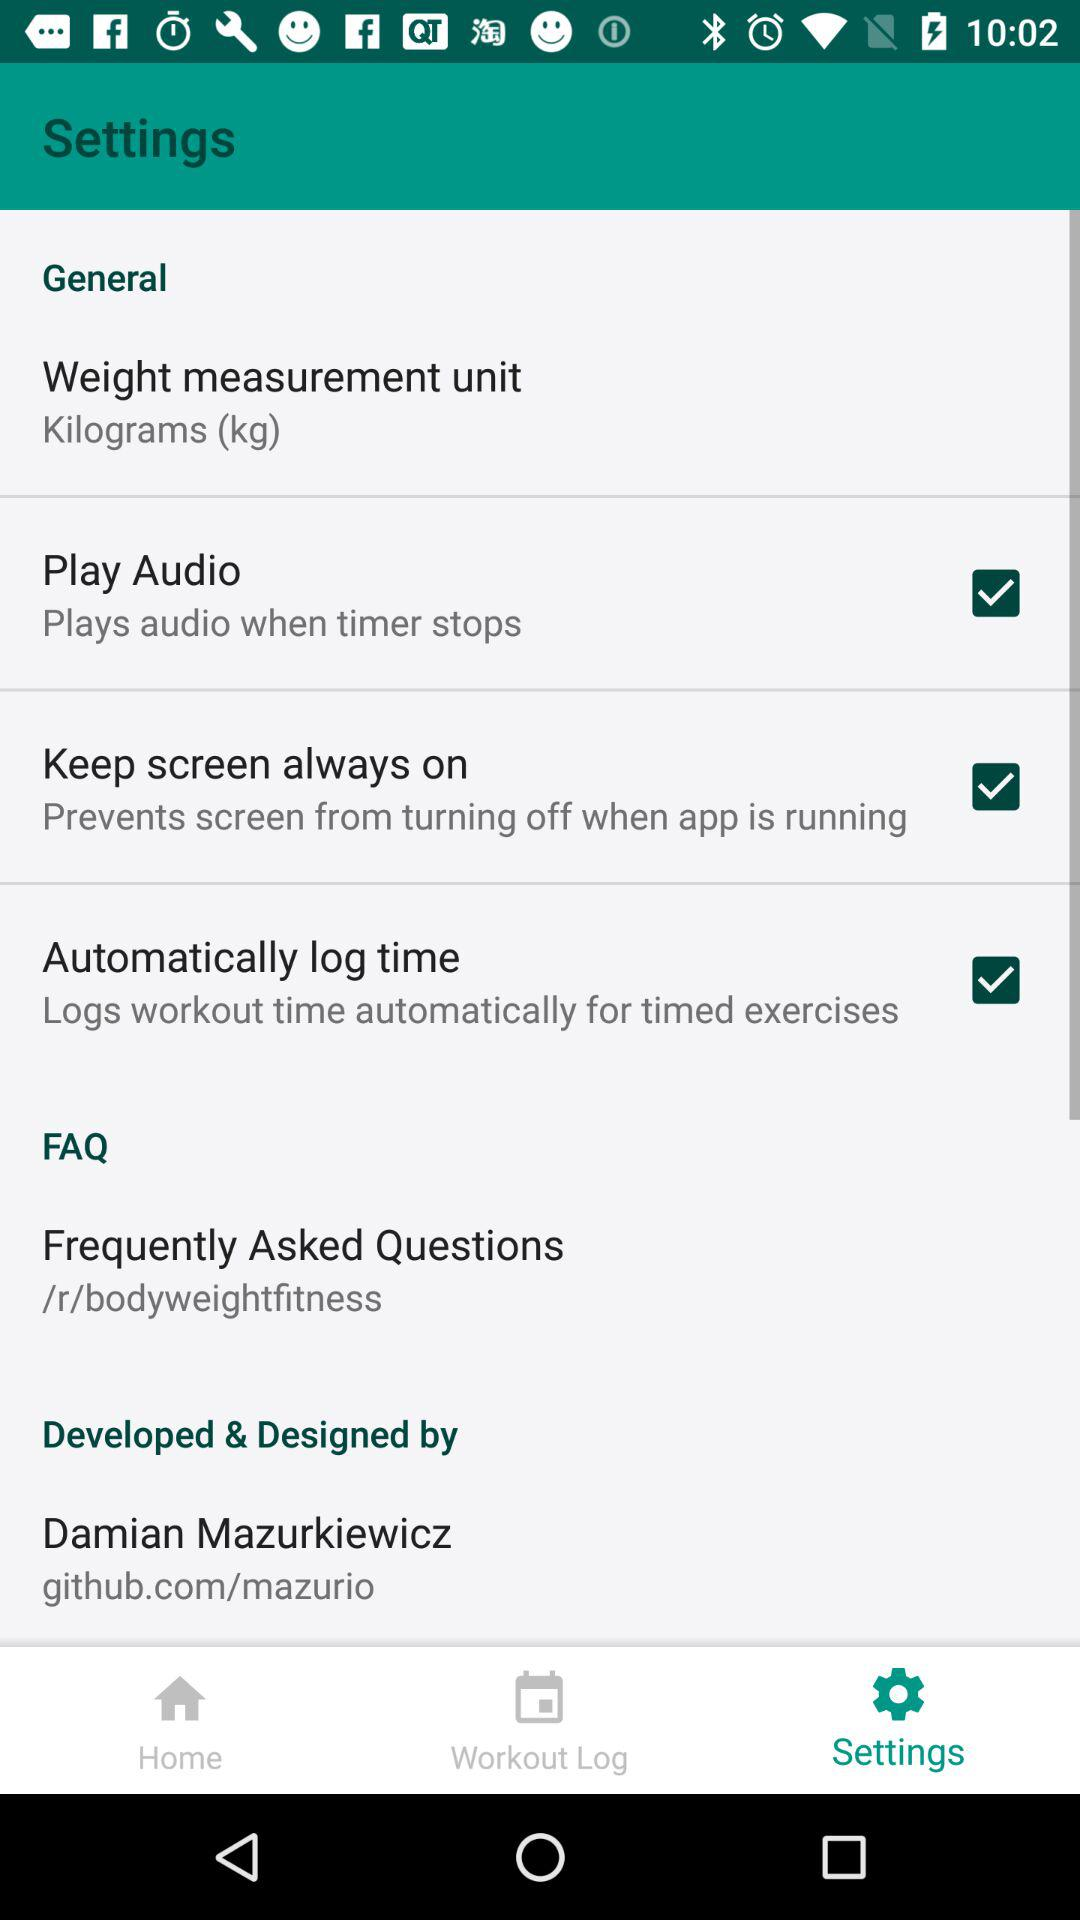Which tab is currently selected? The currently selected tab is "Settings". 